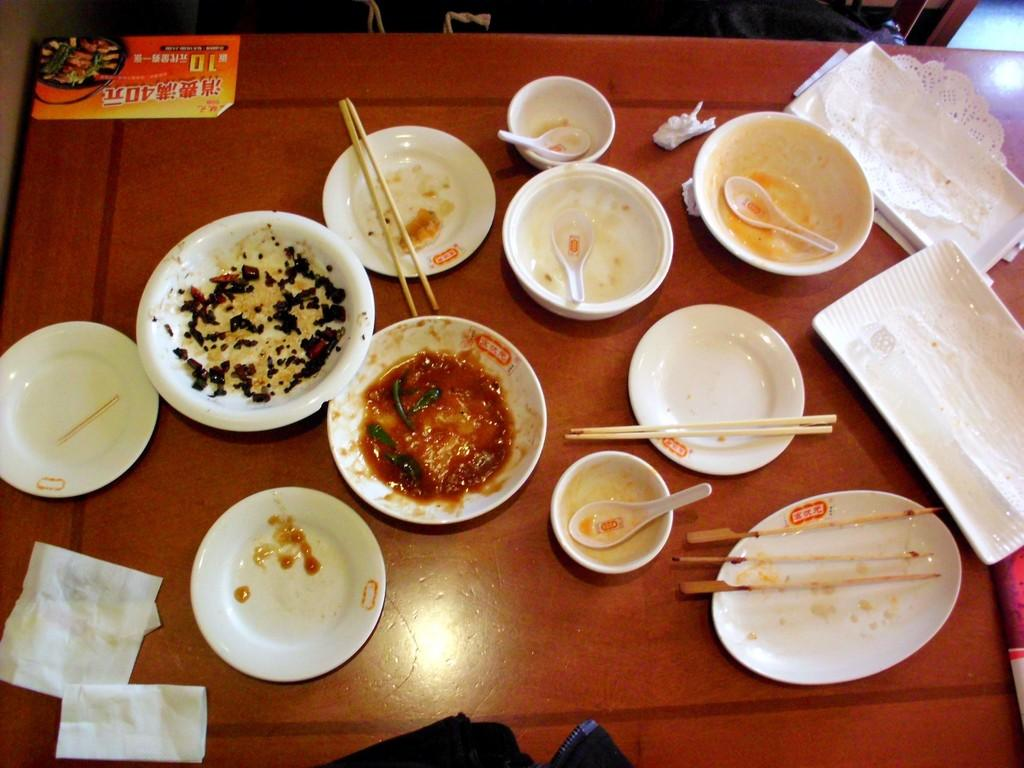What is present on the table in the image? There is a plate, a tissue paper bowl, a spoon, chopsticks, and a tray on the table in the image. What type of utensil can be seen in the image? There is a spoon and chopsticks in the image. What is the container for holding food in the image? There is a plate and a tissue paper bowl in the image. What is the surface on which these items are placed? There is a tray on the table in the image. Are there any other objects visible on the table? Yes, there are other objects on the table in the image. Can you see a swing in the image? No, there is no swing present in the image. Is there a trail leading to the table in the image? No, there is no trail visible in the image. 